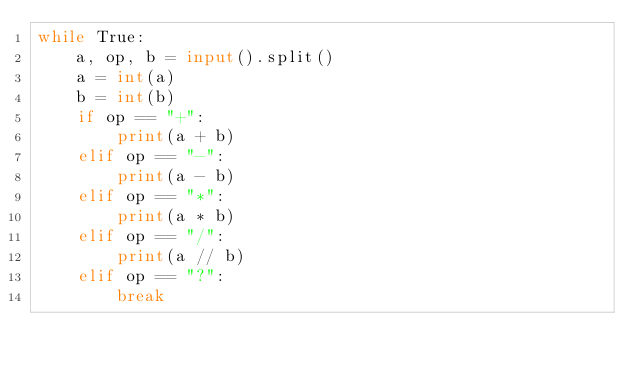Convert code to text. <code><loc_0><loc_0><loc_500><loc_500><_Python_>while True:
    a, op, b = input().split()
    a = int(a)
    b = int(b)
    if op == "+":
        print(a + b)
    elif op == "-":
        print(a - b)
    elif op == "*":
        print(a * b)
    elif op == "/":
        print(a // b)
    elif op == "?":
        break
    
</code> 